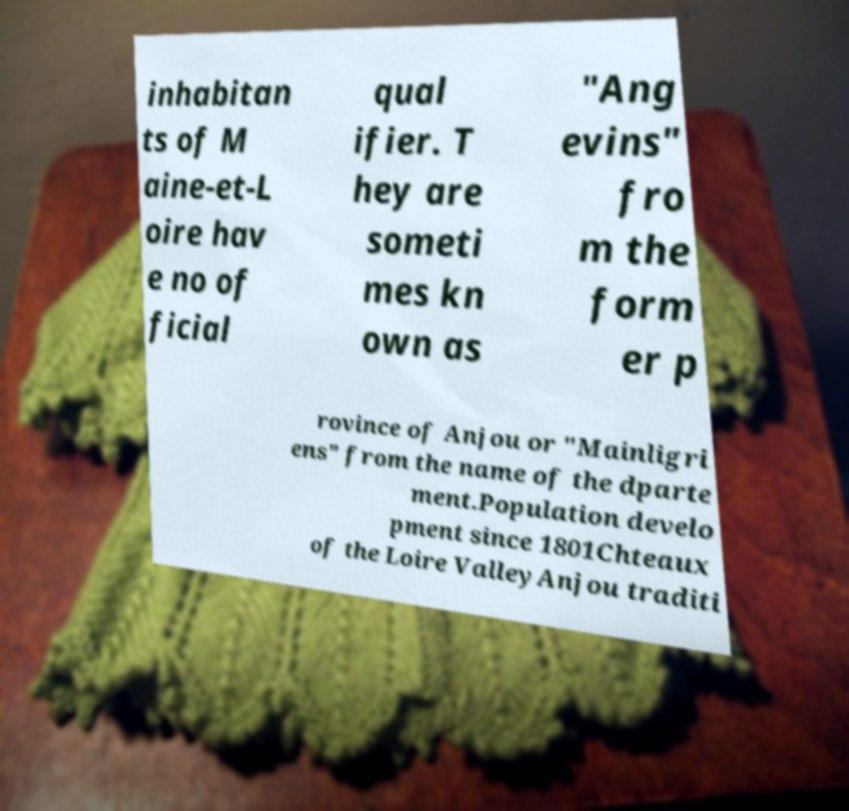Can you accurately transcribe the text from the provided image for me? inhabitan ts of M aine-et-L oire hav e no of ficial qual ifier. T hey are someti mes kn own as "Ang evins" fro m the form er p rovince of Anjou or "Mainligri ens" from the name of the dparte ment.Population develo pment since 1801Chteaux of the Loire ValleyAnjou traditi 